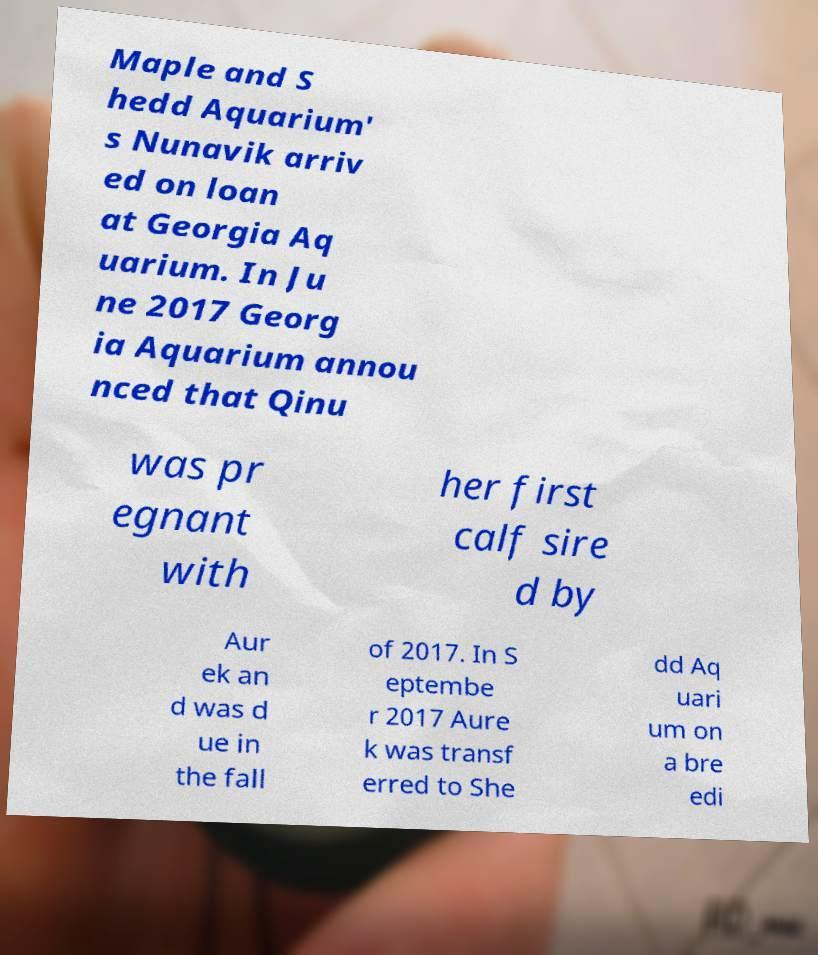There's text embedded in this image that I need extracted. Can you transcribe it verbatim? Maple and S hedd Aquarium' s Nunavik arriv ed on loan at Georgia Aq uarium. In Ju ne 2017 Georg ia Aquarium annou nced that Qinu was pr egnant with her first calf sire d by Aur ek an d was d ue in the fall of 2017. In S eptembe r 2017 Aure k was transf erred to She dd Aq uari um on a bre edi 